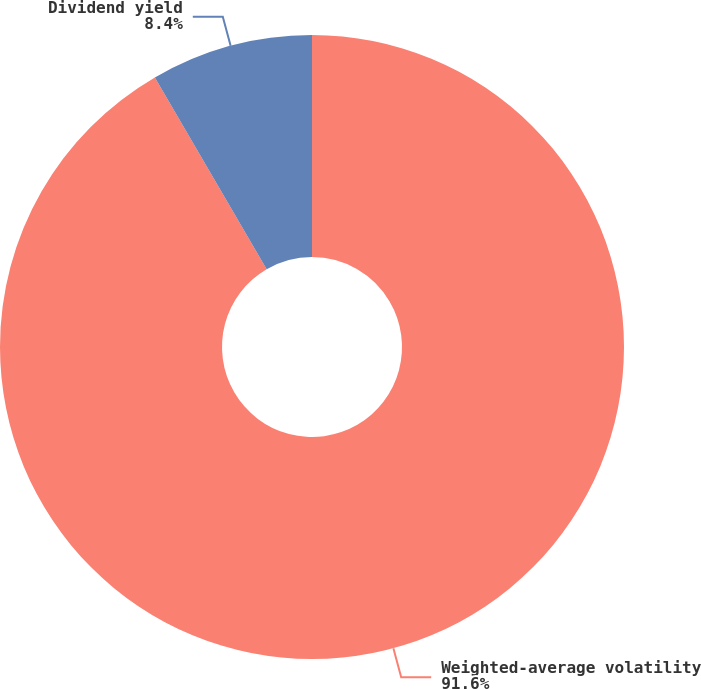Convert chart to OTSL. <chart><loc_0><loc_0><loc_500><loc_500><pie_chart><fcel>Weighted-average volatility<fcel>Dividend yield<nl><fcel>91.6%<fcel>8.4%<nl></chart> 